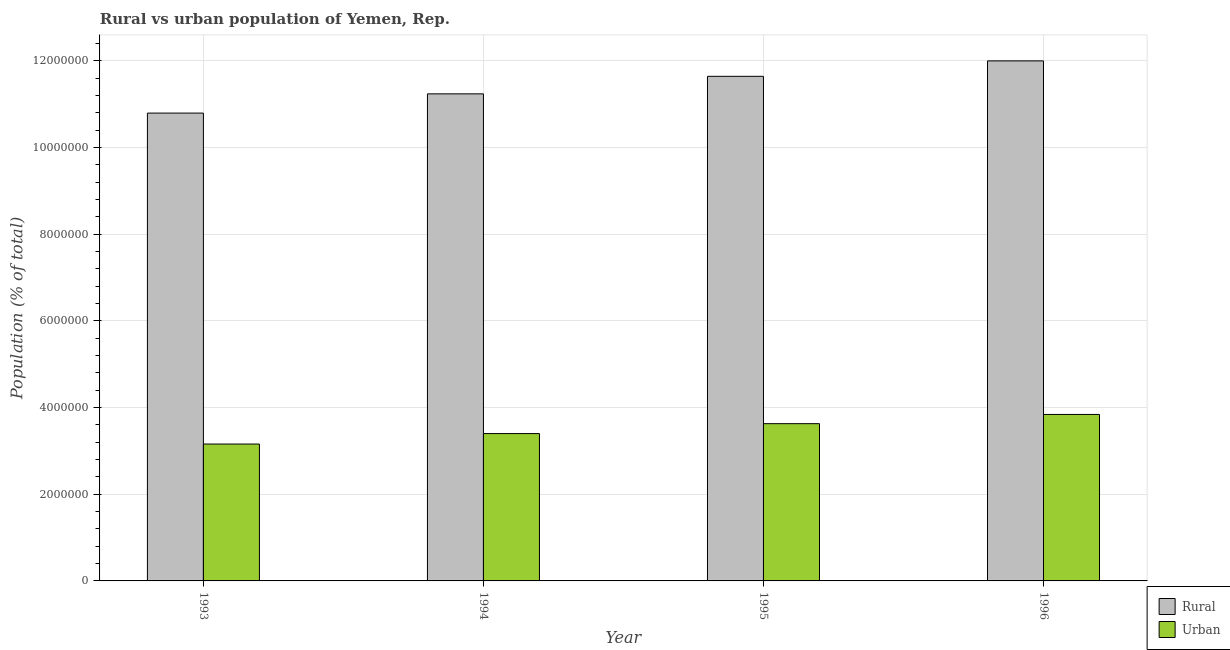How many different coloured bars are there?
Offer a very short reply. 2. How many groups of bars are there?
Keep it short and to the point. 4. How many bars are there on the 3rd tick from the left?
Your response must be concise. 2. What is the label of the 3rd group of bars from the left?
Your response must be concise. 1995. In how many cases, is the number of bars for a given year not equal to the number of legend labels?
Give a very brief answer. 0. What is the rural population density in 1995?
Your response must be concise. 1.16e+07. Across all years, what is the maximum urban population density?
Provide a succinct answer. 3.84e+06. Across all years, what is the minimum rural population density?
Provide a succinct answer. 1.08e+07. In which year was the rural population density maximum?
Ensure brevity in your answer.  1996. What is the total urban population density in the graph?
Ensure brevity in your answer.  1.40e+07. What is the difference between the rural population density in 1995 and that in 1996?
Provide a succinct answer. -3.56e+05. What is the difference between the rural population density in 1994 and the urban population density in 1995?
Give a very brief answer. -4.04e+05. What is the average rural population density per year?
Make the answer very short. 1.14e+07. In the year 1996, what is the difference between the rural population density and urban population density?
Keep it short and to the point. 0. What is the ratio of the rural population density in 1993 to that in 1995?
Ensure brevity in your answer.  0.93. Is the rural population density in 1994 less than that in 1996?
Offer a terse response. Yes. Is the difference between the rural population density in 1993 and 1994 greater than the difference between the urban population density in 1993 and 1994?
Keep it short and to the point. No. What is the difference between the highest and the second highest urban population density?
Your answer should be compact. 2.13e+05. What is the difference between the highest and the lowest rural population density?
Your answer should be compact. 1.20e+06. Is the sum of the urban population density in 1994 and 1996 greater than the maximum rural population density across all years?
Your answer should be very brief. Yes. What does the 1st bar from the left in 1996 represents?
Ensure brevity in your answer.  Rural. What does the 1st bar from the right in 1996 represents?
Offer a terse response. Urban. How many bars are there?
Offer a terse response. 8. Are all the bars in the graph horizontal?
Make the answer very short. No. How many years are there in the graph?
Ensure brevity in your answer.  4. Are the values on the major ticks of Y-axis written in scientific E-notation?
Provide a short and direct response. No. How many legend labels are there?
Ensure brevity in your answer.  2. What is the title of the graph?
Make the answer very short. Rural vs urban population of Yemen, Rep. What is the label or title of the Y-axis?
Ensure brevity in your answer.  Population (% of total). What is the Population (% of total) of Rural in 1993?
Keep it short and to the point. 1.08e+07. What is the Population (% of total) of Urban in 1993?
Ensure brevity in your answer.  3.16e+06. What is the Population (% of total) of Rural in 1994?
Your answer should be very brief. 1.12e+07. What is the Population (% of total) in Urban in 1994?
Keep it short and to the point. 3.40e+06. What is the Population (% of total) of Rural in 1995?
Provide a succinct answer. 1.16e+07. What is the Population (% of total) of Urban in 1995?
Offer a terse response. 3.63e+06. What is the Population (% of total) of Rural in 1996?
Ensure brevity in your answer.  1.20e+07. What is the Population (% of total) in Urban in 1996?
Your answer should be compact. 3.84e+06. Across all years, what is the maximum Population (% of total) of Rural?
Give a very brief answer. 1.20e+07. Across all years, what is the maximum Population (% of total) in Urban?
Your answer should be compact. 3.84e+06. Across all years, what is the minimum Population (% of total) of Rural?
Your answer should be compact. 1.08e+07. Across all years, what is the minimum Population (% of total) in Urban?
Give a very brief answer. 3.16e+06. What is the total Population (% of total) in Rural in the graph?
Give a very brief answer. 4.57e+07. What is the total Population (% of total) in Urban in the graph?
Your answer should be compact. 1.40e+07. What is the difference between the Population (% of total) in Rural in 1993 and that in 1994?
Make the answer very short. -4.44e+05. What is the difference between the Population (% of total) in Urban in 1993 and that in 1994?
Your response must be concise. -2.41e+05. What is the difference between the Population (% of total) of Rural in 1993 and that in 1995?
Make the answer very short. -8.48e+05. What is the difference between the Population (% of total) in Urban in 1993 and that in 1995?
Provide a short and direct response. -4.70e+05. What is the difference between the Population (% of total) of Rural in 1993 and that in 1996?
Your answer should be compact. -1.20e+06. What is the difference between the Population (% of total) in Urban in 1993 and that in 1996?
Offer a terse response. -6.82e+05. What is the difference between the Population (% of total) in Rural in 1994 and that in 1995?
Your response must be concise. -4.04e+05. What is the difference between the Population (% of total) in Urban in 1994 and that in 1995?
Ensure brevity in your answer.  -2.29e+05. What is the difference between the Population (% of total) in Rural in 1994 and that in 1996?
Offer a very short reply. -7.60e+05. What is the difference between the Population (% of total) in Urban in 1994 and that in 1996?
Make the answer very short. -4.41e+05. What is the difference between the Population (% of total) in Rural in 1995 and that in 1996?
Your answer should be compact. -3.56e+05. What is the difference between the Population (% of total) in Urban in 1995 and that in 1996?
Keep it short and to the point. -2.13e+05. What is the difference between the Population (% of total) in Rural in 1993 and the Population (% of total) in Urban in 1994?
Your answer should be very brief. 7.39e+06. What is the difference between the Population (% of total) of Rural in 1993 and the Population (% of total) of Urban in 1995?
Your answer should be very brief. 7.16e+06. What is the difference between the Population (% of total) in Rural in 1993 and the Population (% of total) in Urban in 1996?
Your answer should be compact. 6.95e+06. What is the difference between the Population (% of total) of Rural in 1994 and the Population (% of total) of Urban in 1995?
Your answer should be compact. 7.61e+06. What is the difference between the Population (% of total) of Rural in 1994 and the Population (% of total) of Urban in 1996?
Offer a very short reply. 7.39e+06. What is the difference between the Population (% of total) in Rural in 1995 and the Population (% of total) in Urban in 1996?
Offer a terse response. 7.80e+06. What is the average Population (% of total) in Rural per year?
Provide a short and direct response. 1.14e+07. What is the average Population (% of total) in Urban per year?
Provide a succinct answer. 3.51e+06. In the year 1993, what is the difference between the Population (% of total) in Rural and Population (% of total) in Urban?
Offer a terse response. 7.63e+06. In the year 1994, what is the difference between the Population (% of total) of Rural and Population (% of total) of Urban?
Make the answer very short. 7.84e+06. In the year 1995, what is the difference between the Population (% of total) of Rural and Population (% of total) of Urban?
Your answer should be compact. 8.01e+06. In the year 1996, what is the difference between the Population (% of total) of Rural and Population (% of total) of Urban?
Keep it short and to the point. 8.16e+06. What is the ratio of the Population (% of total) in Rural in 1993 to that in 1994?
Provide a short and direct response. 0.96. What is the ratio of the Population (% of total) in Urban in 1993 to that in 1994?
Keep it short and to the point. 0.93. What is the ratio of the Population (% of total) in Rural in 1993 to that in 1995?
Offer a terse response. 0.93. What is the ratio of the Population (% of total) in Urban in 1993 to that in 1995?
Your answer should be very brief. 0.87. What is the ratio of the Population (% of total) of Rural in 1993 to that in 1996?
Your response must be concise. 0.9. What is the ratio of the Population (% of total) of Urban in 1993 to that in 1996?
Your answer should be very brief. 0.82. What is the ratio of the Population (% of total) of Rural in 1994 to that in 1995?
Offer a terse response. 0.97. What is the ratio of the Population (% of total) in Urban in 1994 to that in 1995?
Keep it short and to the point. 0.94. What is the ratio of the Population (% of total) in Rural in 1994 to that in 1996?
Give a very brief answer. 0.94. What is the ratio of the Population (% of total) in Urban in 1994 to that in 1996?
Offer a very short reply. 0.89. What is the ratio of the Population (% of total) in Rural in 1995 to that in 1996?
Make the answer very short. 0.97. What is the ratio of the Population (% of total) of Urban in 1995 to that in 1996?
Give a very brief answer. 0.94. What is the difference between the highest and the second highest Population (% of total) of Rural?
Ensure brevity in your answer.  3.56e+05. What is the difference between the highest and the second highest Population (% of total) in Urban?
Provide a short and direct response. 2.13e+05. What is the difference between the highest and the lowest Population (% of total) of Rural?
Offer a very short reply. 1.20e+06. What is the difference between the highest and the lowest Population (% of total) of Urban?
Ensure brevity in your answer.  6.82e+05. 